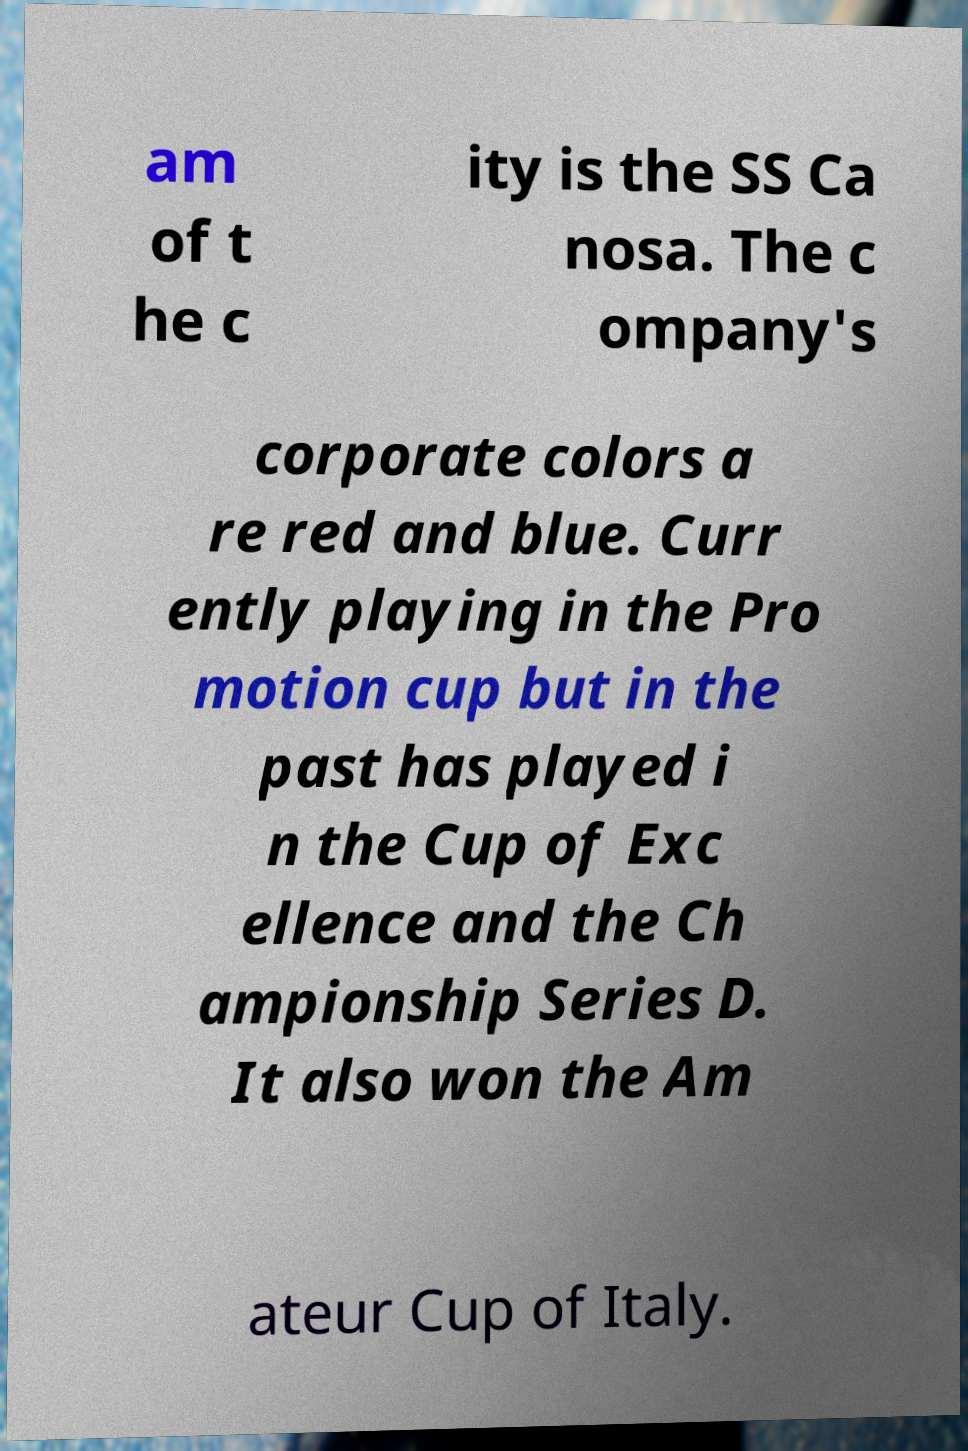Please identify and transcribe the text found in this image. am of t he c ity is the SS Ca nosa. The c ompany's corporate colors a re red and blue. Curr ently playing in the Pro motion cup but in the past has played i n the Cup of Exc ellence and the Ch ampionship Series D. It also won the Am ateur Cup of Italy. 